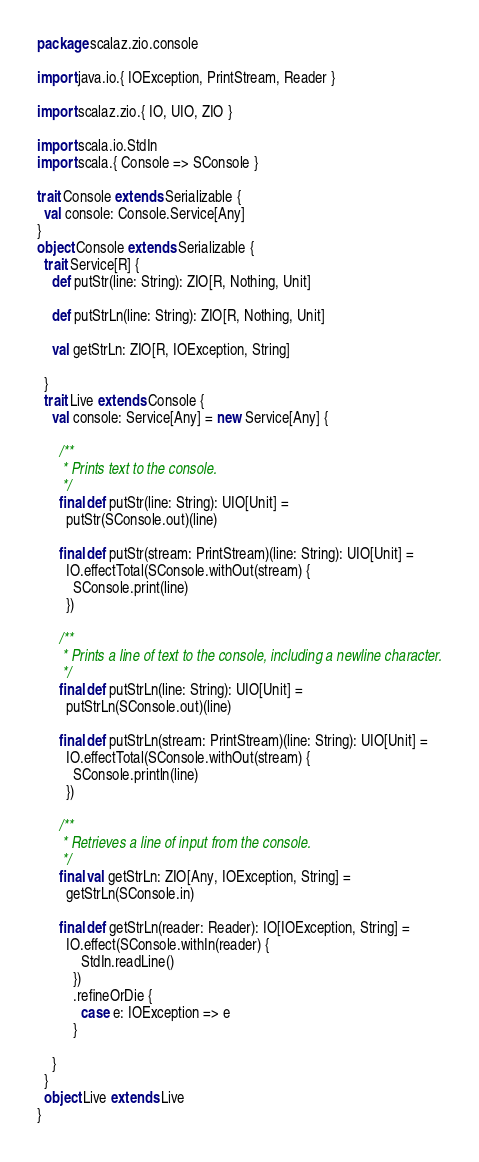Convert code to text. <code><loc_0><loc_0><loc_500><loc_500><_Scala_>package scalaz.zio.console

import java.io.{ IOException, PrintStream, Reader }

import scalaz.zio.{ IO, UIO, ZIO }

import scala.io.StdIn
import scala.{ Console => SConsole }

trait Console extends Serializable {
  val console: Console.Service[Any]
}
object Console extends Serializable {
  trait Service[R] {
    def putStr(line: String): ZIO[R, Nothing, Unit]

    def putStrLn(line: String): ZIO[R, Nothing, Unit]

    val getStrLn: ZIO[R, IOException, String]

  }
  trait Live extends Console {
    val console: Service[Any] = new Service[Any] {

      /**
       * Prints text to the console.
       */
      final def putStr(line: String): UIO[Unit] =
        putStr(SConsole.out)(line)

      final def putStr(stream: PrintStream)(line: String): UIO[Unit] =
        IO.effectTotal(SConsole.withOut(stream) {
          SConsole.print(line)
        })

      /**
       * Prints a line of text to the console, including a newline character.
       */
      final def putStrLn(line: String): UIO[Unit] =
        putStrLn(SConsole.out)(line)

      final def putStrLn(stream: PrintStream)(line: String): UIO[Unit] =
        IO.effectTotal(SConsole.withOut(stream) {
          SConsole.println(line)
        })

      /**
       * Retrieves a line of input from the console.
       */
      final val getStrLn: ZIO[Any, IOException, String] =
        getStrLn(SConsole.in)

      final def getStrLn(reader: Reader): IO[IOException, String] =
        IO.effect(SConsole.withIn(reader) {
            StdIn.readLine()
          })
          .refineOrDie {
            case e: IOException => e
          }

    }
  }
  object Live extends Live
}
</code> 